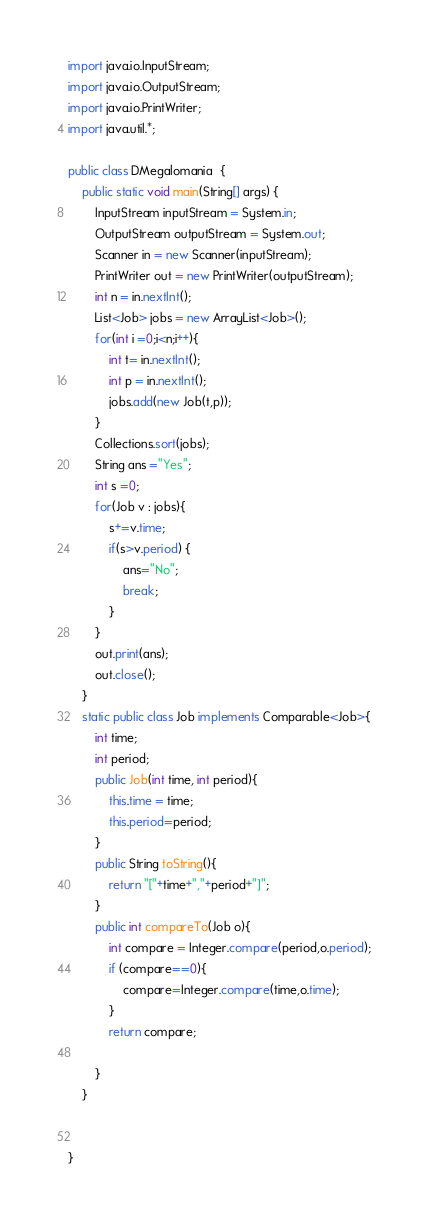<code> <loc_0><loc_0><loc_500><loc_500><_Java_>import java.io.InputStream;
import java.io.OutputStream;
import java.io.PrintWriter;
import java.util.*;

public class DMegalomania  {
    public static void main(String[] args) {
        InputStream inputStream = System.in;
        OutputStream outputStream = System.out;
        Scanner in = new Scanner(inputStream);
        PrintWriter out = new PrintWriter(outputStream);
        int n = in.nextInt();
        List<Job> jobs = new ArrayList<Job>();
        for(int i =0;i<n;i++){
            int t= in.nextInt();
            int p = in.nextInt();
            jobs.add(new Job(t,p));
        }
        Collections.sort(jobs);
        String ans ="Yes";
        int s =0;
        for(Job v : jobs){
            s+=v.time;
            if(s>v.period) {
                ans="No";
                break;
            }
        }
        out.print(ans);
        out.close();
    }
    static public class Job implements Comparable<Job>{
        int time;
        int period;
        public Job(int time, int period){
            this.time = time;
            this.period=period;
        }
        public String toString(){
            return "["+time+","+period+"]";
        }
        public int compareTo(Job o){
            int compare = Integer.compare(period,o.period);
            if (compare==0){
                compare=Integer.compare(time,o.time);
            }
            return compare;

        }
    }


}
</code> 